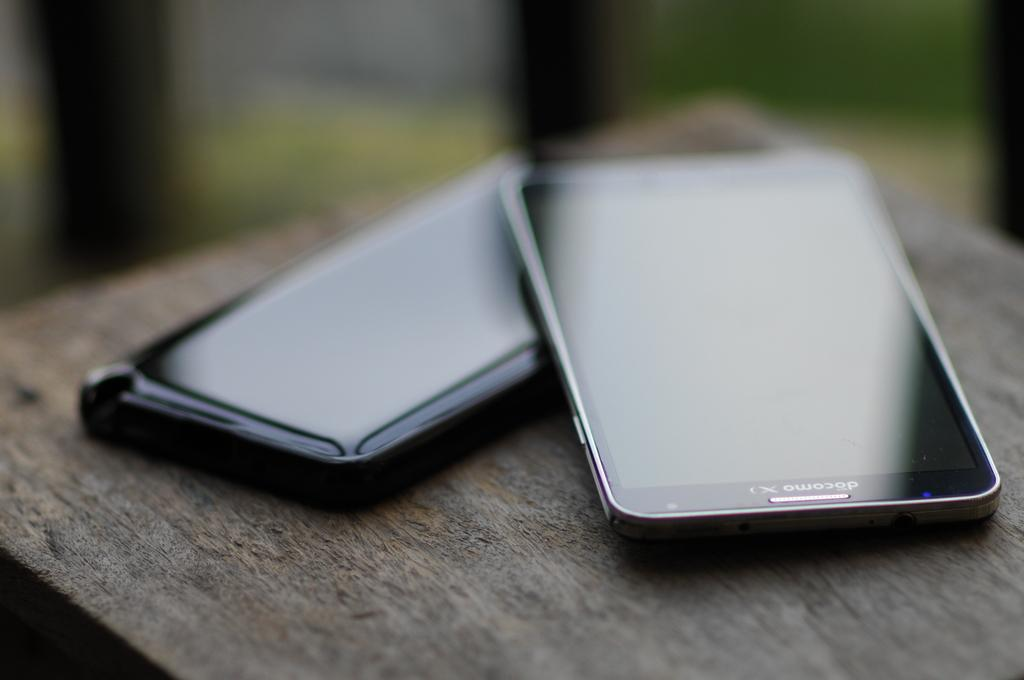Provide a one-sentence caption for the provided image. A close up of two mobile phones, one resting on the other with screens that cannot be seen because of light glare. 